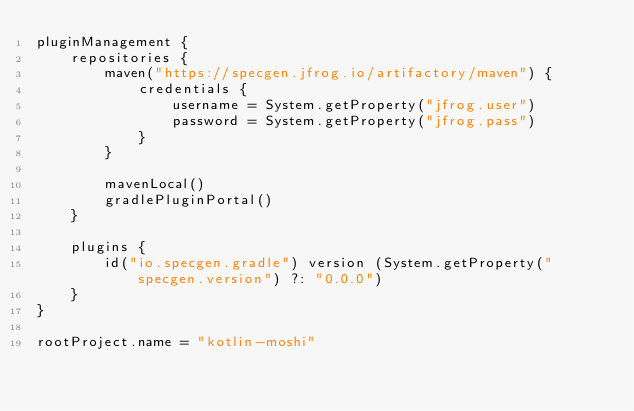<code> <loc_0><loc_0><loc_500><loc_500><_Kotlin_>pluginManagement {
    repositories {
        maven("https://specgen.jfrog.io/artifactory/maven") {
            credentials {
                username = System.getProperty("jfrog.user")
                password = System.getProperty("jfrog.pass")
            }
        }

        mavenLocal()
        gradlePluginPortal()
    }

    plugins {
        id("io.specgen.gradle") version (System.getProperty("specgen.version") ?: "0.0.0")
    }
}

rootProject.name = "kotlin-moshi"
</code> 